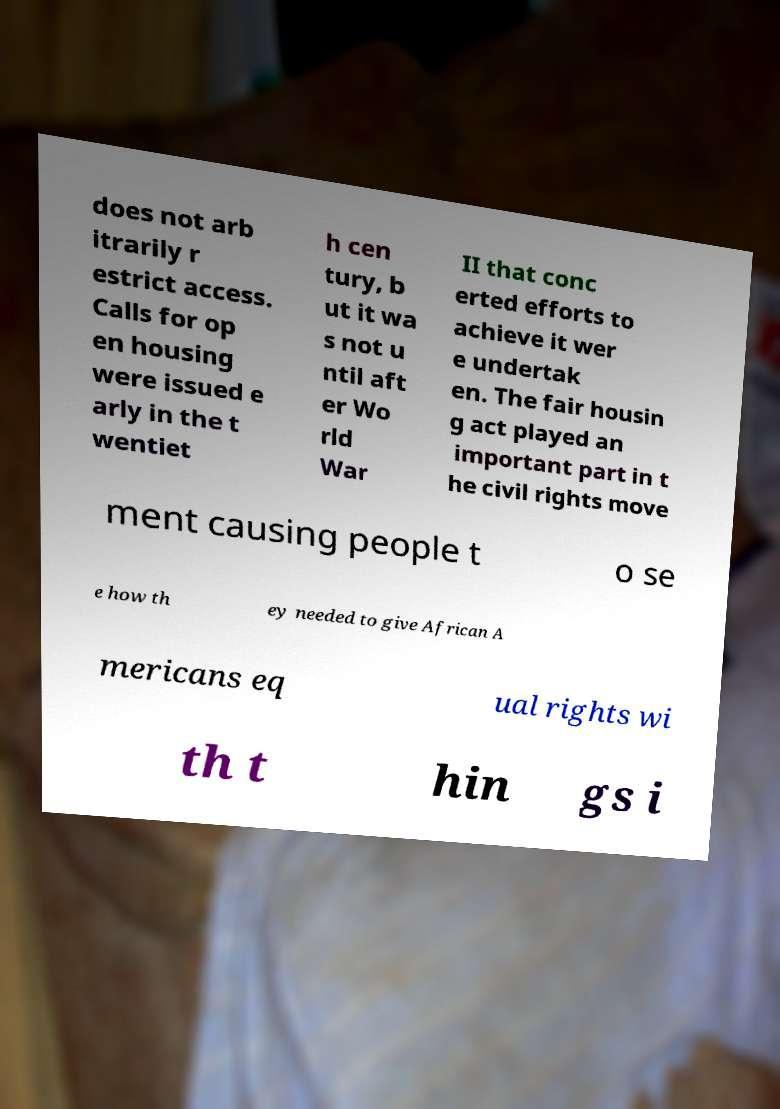I need the written content from this picture converted into text. Can you do that? does not arb itrarily r estrict access. Calls for op en housing were issued e arly in the t wentiet h cen tury, b ut it wa s not u ntil aft er Wo rld War II that conc erted efforts to achieve it wer e undertak en. The fair housin g act played an important part in t he civil rights move ment causing people t o se e how th ey needed to give African A mericans eq ual rights wi th t hin gs i 